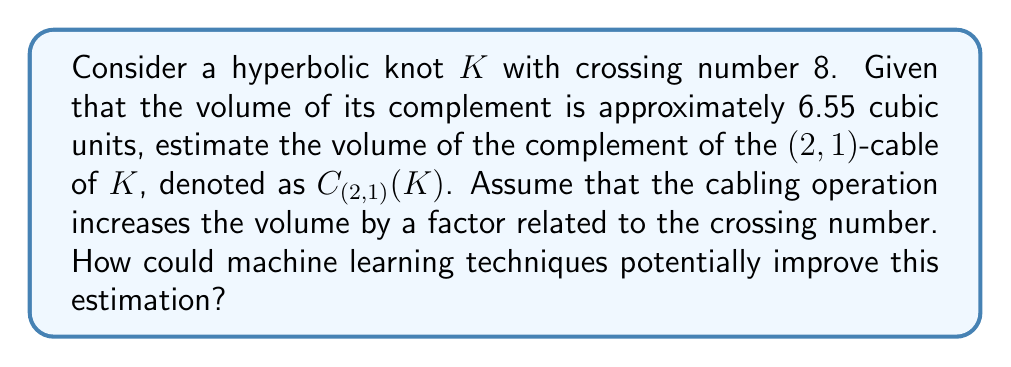Solve this math problem. 1) First, let's recall that for a hyperbolic knot $K$, the volume of its complement, $V(S^3 \setminus K)$, is a topological invariant.

2) The $(2,1)$-cable of $K$, denoted as $C_{(2,1)}(K)$, wraps around $K$ twice in the longitudinal direction and once in the meridional direction.

3) While there's no exact formula for the volume of cable knot complements, empirical studies suggest that cabling operations tend to increase the volume.

4) A rough estimation based on the crossing number can be used:

   $V(S^3 \setminus C_{(2,1)}(K)) \approx V(S^3 \setminus K) \cdot (1 + \frac{c(K)}{100})$

   where $c(K)$ is the crossing number of $K$.

5) Given:
   - $c(K) = 8$
   - $V(S^3 \setminus K) \approx 6.55$

6) Applying the estimation:

   $V(S^3 \setminus C_{(2,1)}(K)) \approx 6.55 \cdot (1 + \frac{8}{100}) = 6.55 \cdot 1.08 \approx 7.074$

7) Machine learning techniques could potentially improve this estimation by:
   - Training on a large dataset of known knot complements and their volumes
   - Incorporating more features beyond just crossing number (e.g., Jones polynomial coefficients, Alexander polynomial)
   - Using neural networks to capture complex relationships between knot properties and complement volumes
   - Employing techniques like transfer learning from simpler knots to more complex ones

8) A ML model could potentially provide a more accurate estimate and even quantify the uncertainty in its prediction.
Answer: $\approx 7.074$ cubic units; ML could improve by learning from large datasets and incorporating more knot invariants. 